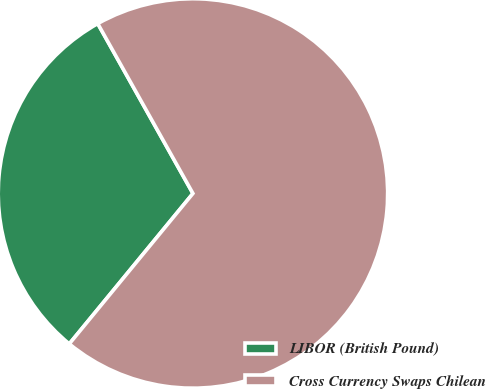<chart> <loc_0><loc_0><loc_500><loc_500><pie_chart><fcel>LIBOR (British Pound)<fcel>Cross Currency Swaps Chilean<nl><fcel>30.92%<fcel>69.08%<nl></chart> 